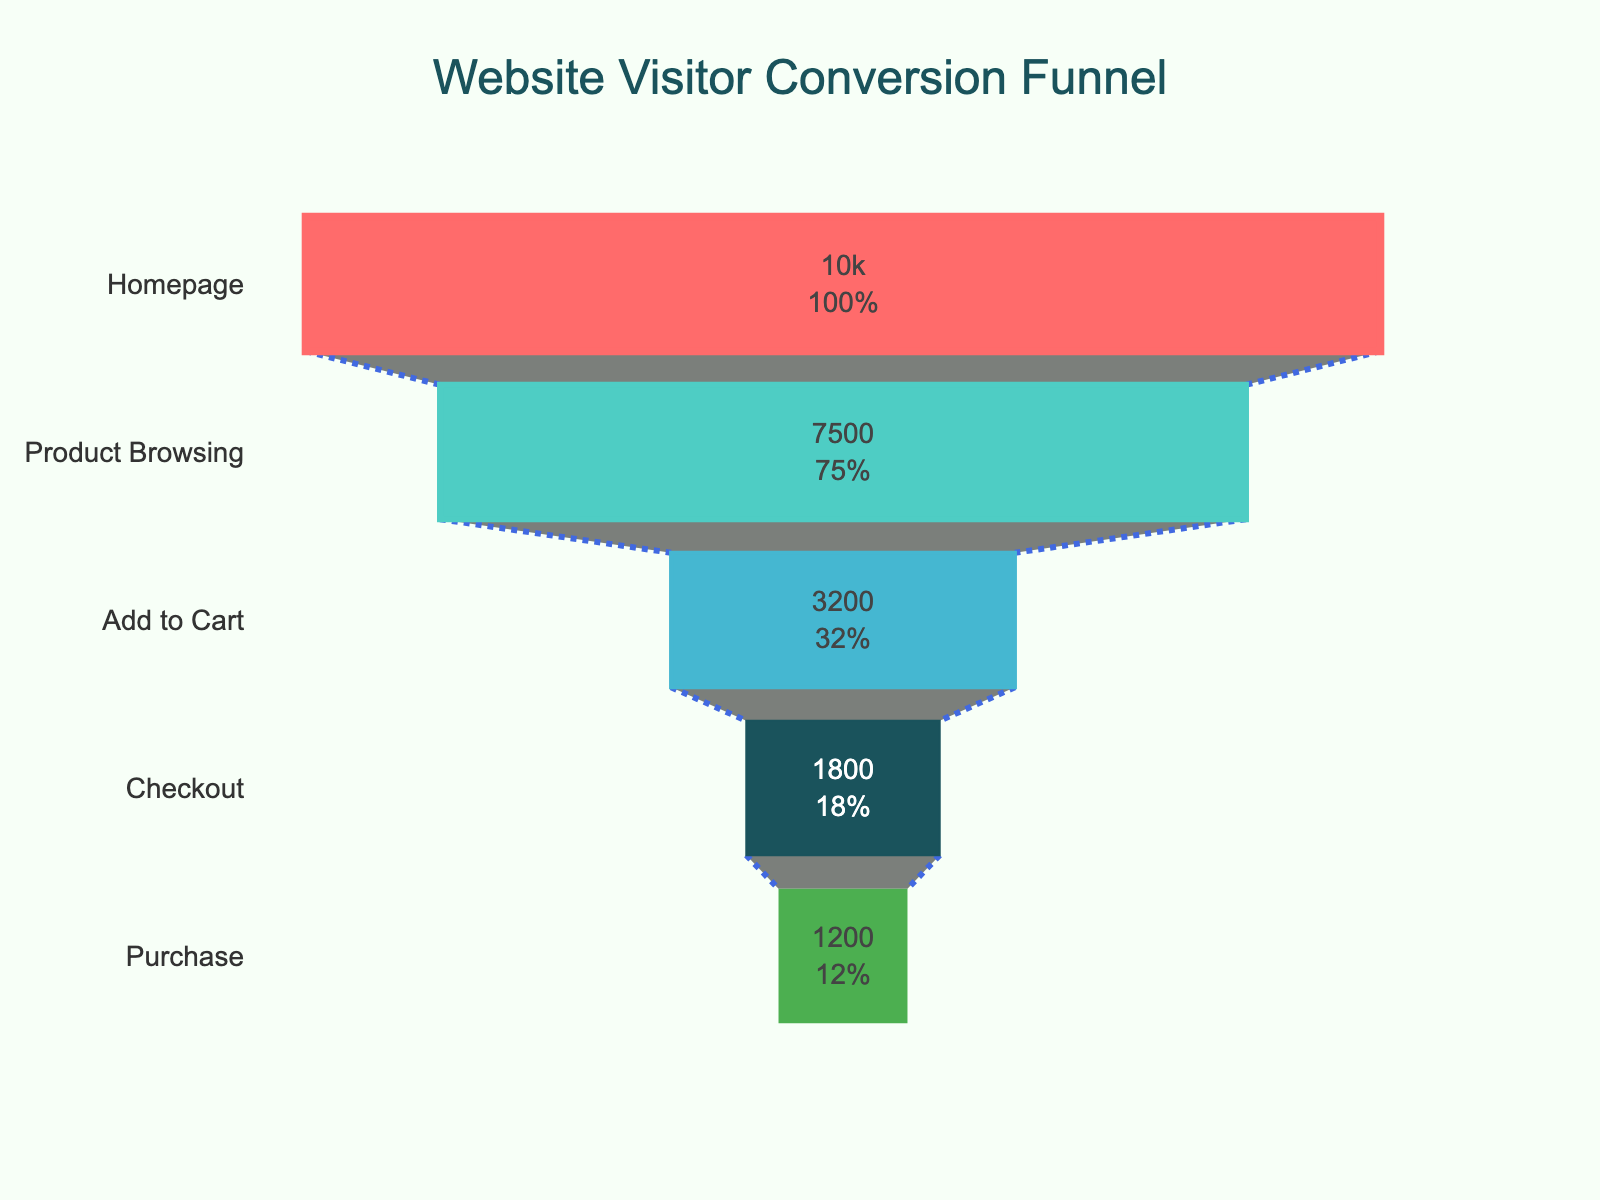what is the title of the chart? The chart title is usually located at the top of the figure. In this case, it reads "Website Visitor Conversion Funnel."
Answer: Website Visitor Conversion Funnel How many visitors reach the 'Add to Cart' stage? By referencing the figure, look at the "Add to Cart" stage and note the number of visitors, which is displayed inside the funnel shape.
Answer: 3200 What percentage of visitors make a purchase? First, find the total number of visitors at the Homepage stage which is 10000. Then, find the number of visitors who reach the Purchase stage which is 1200. Calculate the percentage: (1200 / 10000) * 100 = 12%.
Answer: 12% How many more visitors browse products than proceed to checkout? Identify the number of visitors at the "Product Browsing" stage (7500) and the "Checkout" stage (1800). Subtract the latter from the former: 7500 - 1800 = 5700.
Answer: 5700 Which stage has the largest drop-off in visitors? Compare the difference in visitor numbers between consecutive stages. The biggest drop-off is observed between "Product Browsing" (7500) and "Add to Cart" (3200), with a drop of 7500 - 3200 = 4300.
Answer: Product Browsing to Add to Cart What is the color used for the 'Checkout' stage? Refer to the color legend or the mentioned colors in the funnel to identify the color used for the Checkout stage, which is the fourth color. The color is described as "#1A535C" in the code, which is a dark teal.
Answer: dark teal Can you list the stages in order from highest to lowest number of visitors? The order can be identified by looking at the x-axis values for each stage. It goes from Homepage (10000), Product Browsing (7500), Add to Cart (3200), Checkout (1800), to Purchase (1200).
Answer: Homepage, Product Browsing, Add to Cart, Checkout, Purchase What percent of the initial visitors add products to their cart? The initial number of visitors is at the Homepage stage (10000), and the number of visitors who add to the cart is 3200. Calculate the percentage: (3200 / 10000) * 100 = 32%.
Answer: 32% What is the difference in visitor numbers from 'Product Browsing' to 'Purchase'? Count the visitors at "Product Browsing" (7500) and at "Purchase" (1200). Subtract the latter from the former: 7500 - 1200 = 6300.
Answer: 6300 Which stage has the least number of visitors? Identify the stage with the smallest number on the x-axis, which is the "Purchase" stage with 1200 visitors.
Answer: Purchase 